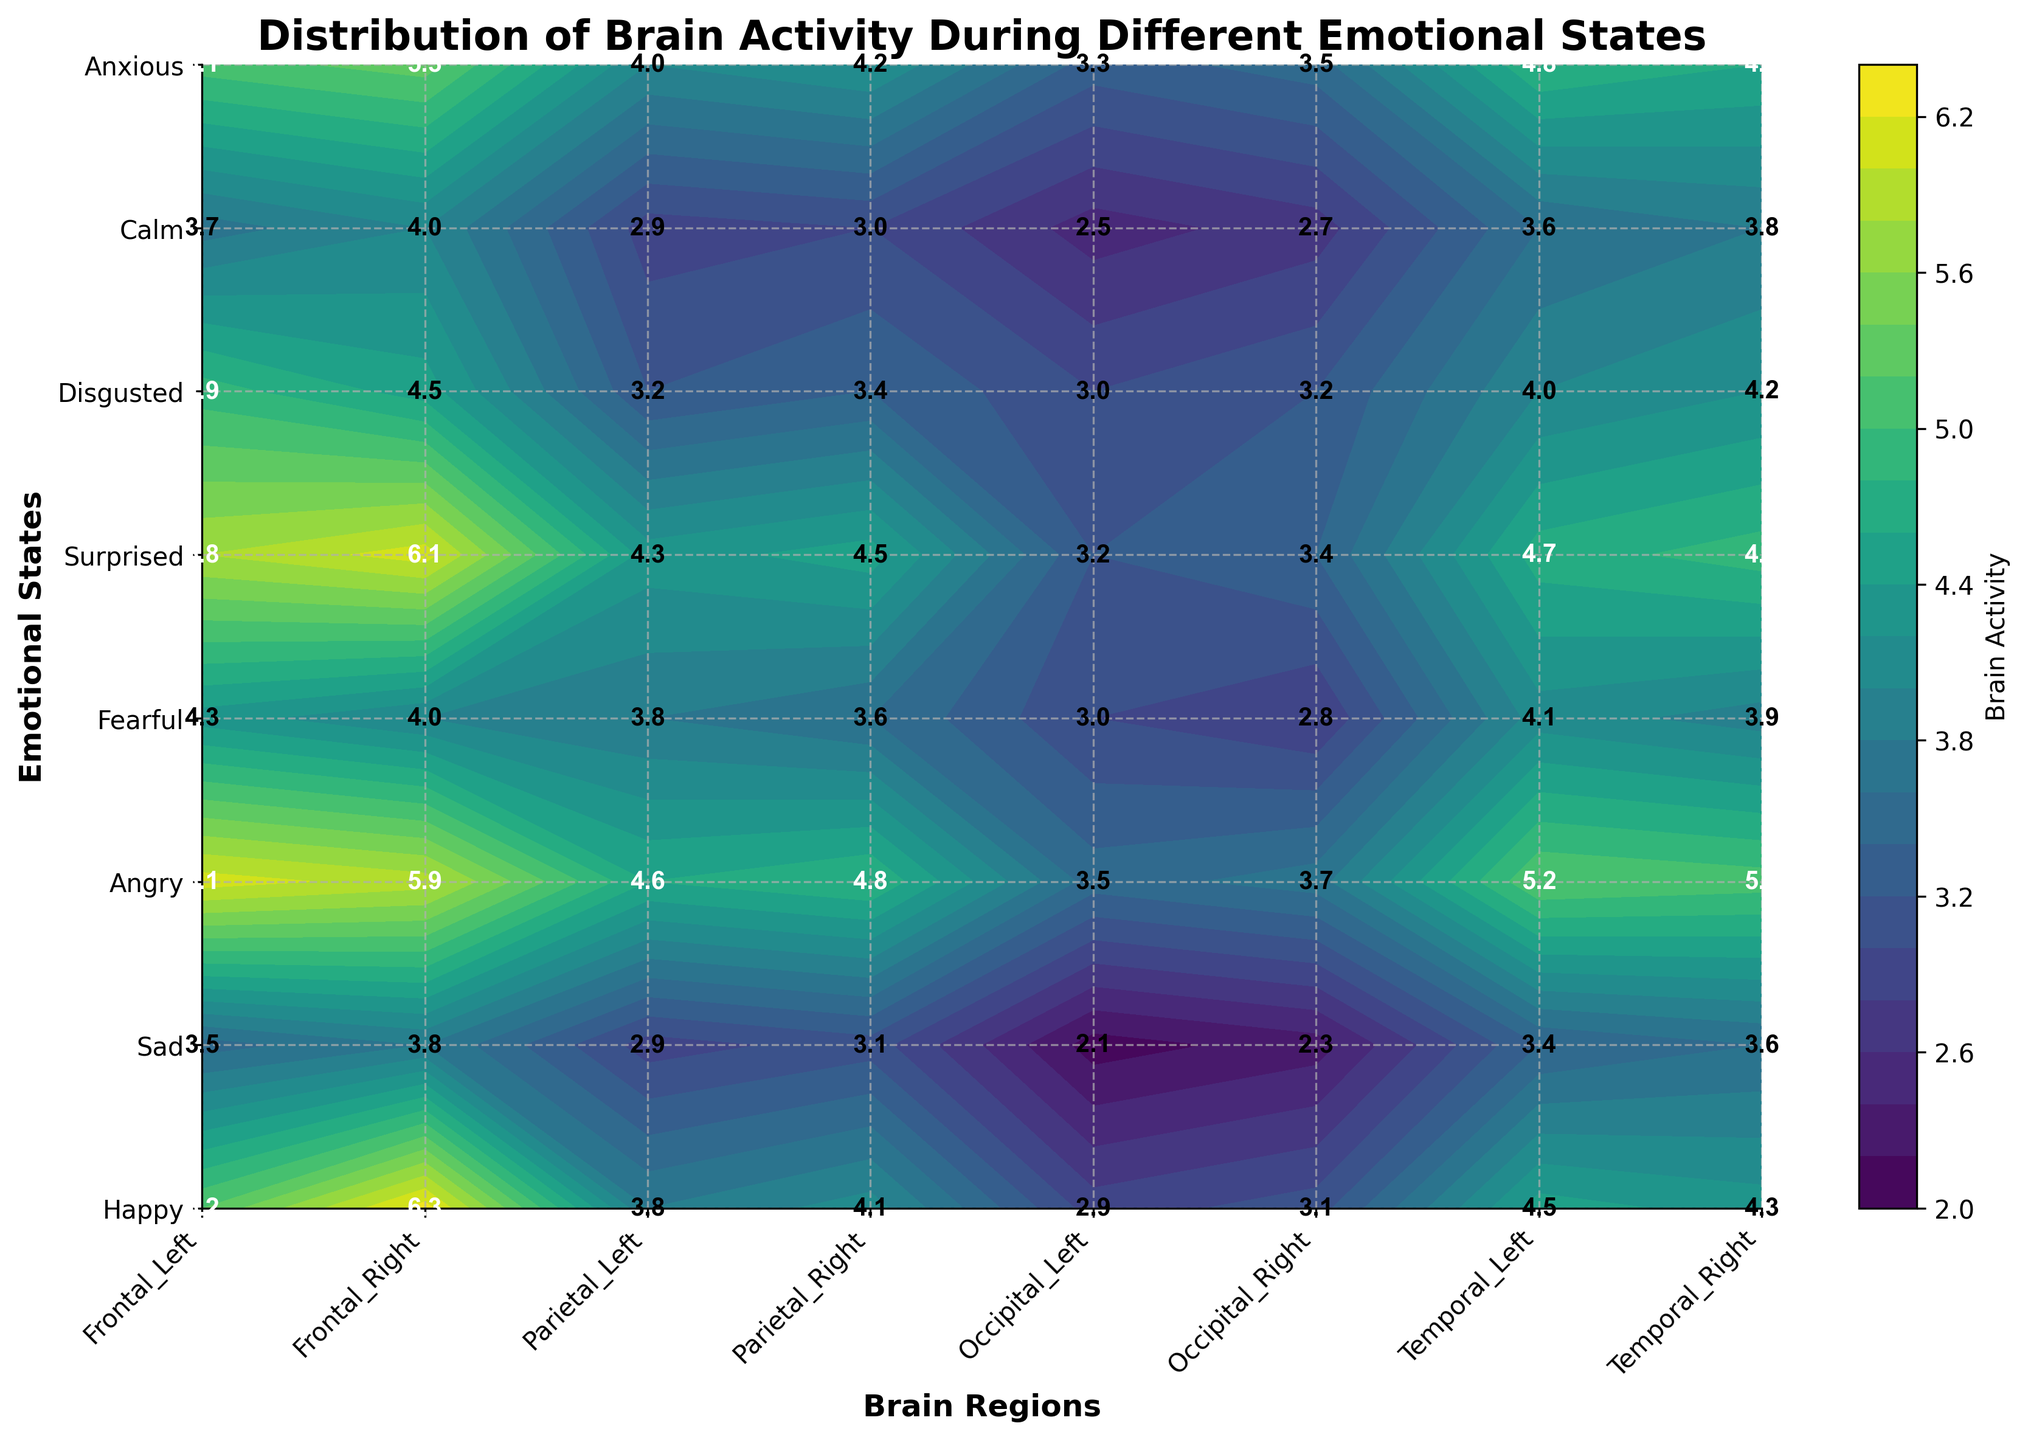Which emotional state shows the highest brain activity in the Frontal Left region? To find this, look at the Frontal Left region and identify the highest value among emotional states. "Angry" shows the highest value of 6.1.
Answer: Angry What is the average brain activity in the Temporal Right region across all emotional states? To calculate the average, sum the values of the Temporal Right region for all states and divide by the number of states. The sum is (4.3 + 3.6 + 5.1 + 3.9 + 4.9 + 4.2 + 3.8 + 4.6) = 34.4. There are 8 states, so 34.4 / 8 = 4.3.
Answer: 4.3 Which emotional state has the lowest brain activity in the Occipital Left region? To determine this, look at the Occipital Left region and identify the lowest value among emotional states. "Sad" has the lowest value of 2.1.
Answer: Sad Compare the brain activity in the Parietal Right region between Happy and Sad emotional states. Which one is higher and by how much? Check the values for Happy (4.1) and Sad (3.1) in the Parietal Right region. The difference is 4.1 - 3.1 = 1.0. Therefore, Happy is higher by 1.0.
Answer: Happy by 1.0 Which brain region shows the most variable brain activity across different emotional states? To find the most variable region, compare the range (max - min) of values in each brain region. The Temporal_Right region has the highest range (5.1 - 3.6 = 1.5).
Answer: Temporal_Right Are there any brain regions where the Sad and Calm emotional states show the same level of activity? Check the values for Sad and Calm in each brain region. In the Parietal_Left region, both have a value of 2.9.
Answer: Parietal_Left What is the maximum recorded brain activity for the Fearful state, and in which region does it occur? Find the highest value for the Fearful state across all regions. The highest value is 4.3, occurring in the Parietal_Left and Frontal_Left regions.
Answer: 4.3 in Parietal_Left and Frontal_Left How does the brain activity in the Temporal_Left region for the Angry state compare to the Happy state? Locate the values for Angry (5.2) and Happy (4.5) in the Temporal_Left region. The Angry state is higher by 5.2 - 4.5 = 0.7.
Answer: Angry is higher by 0.7 